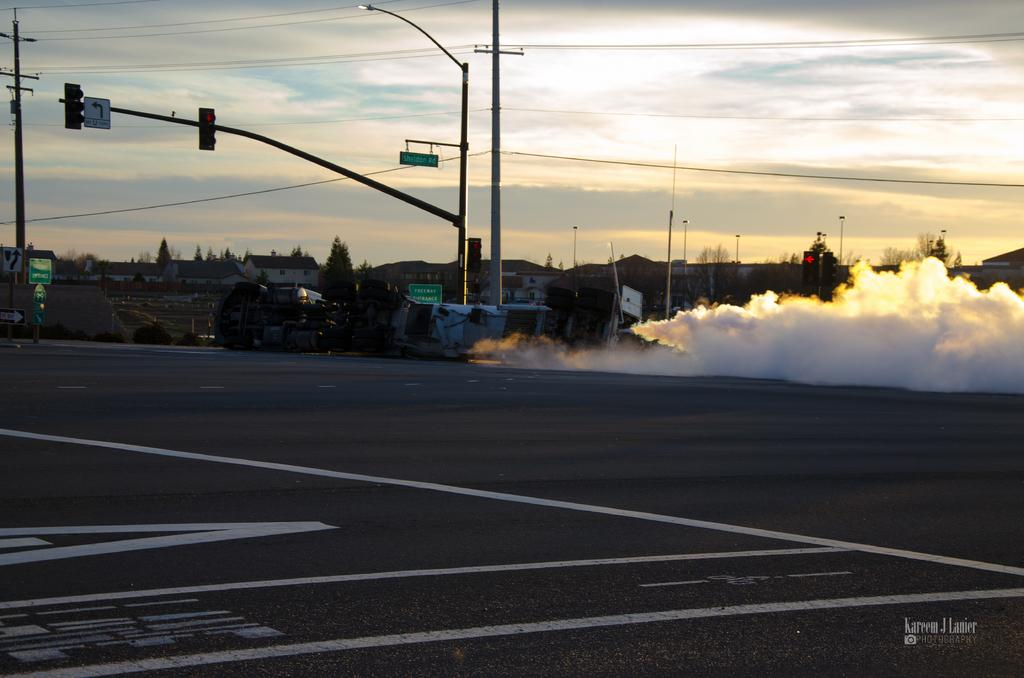What is the main feature of the image? There is a road in the image. What else can be seen along the road? There are poles, a traffic signal, wires, and boards in the image. Is there any sign of transportation in the image? Yes, there is a vehicle in the image. What can be seen in the background of the image? There are buildings, trees, and the sky visible in the background of the image. Where is the throne located in the image? There is no throne present in the image. What type of food is the cook preparing in the image? There is no cook or food preparation visible in the image. 